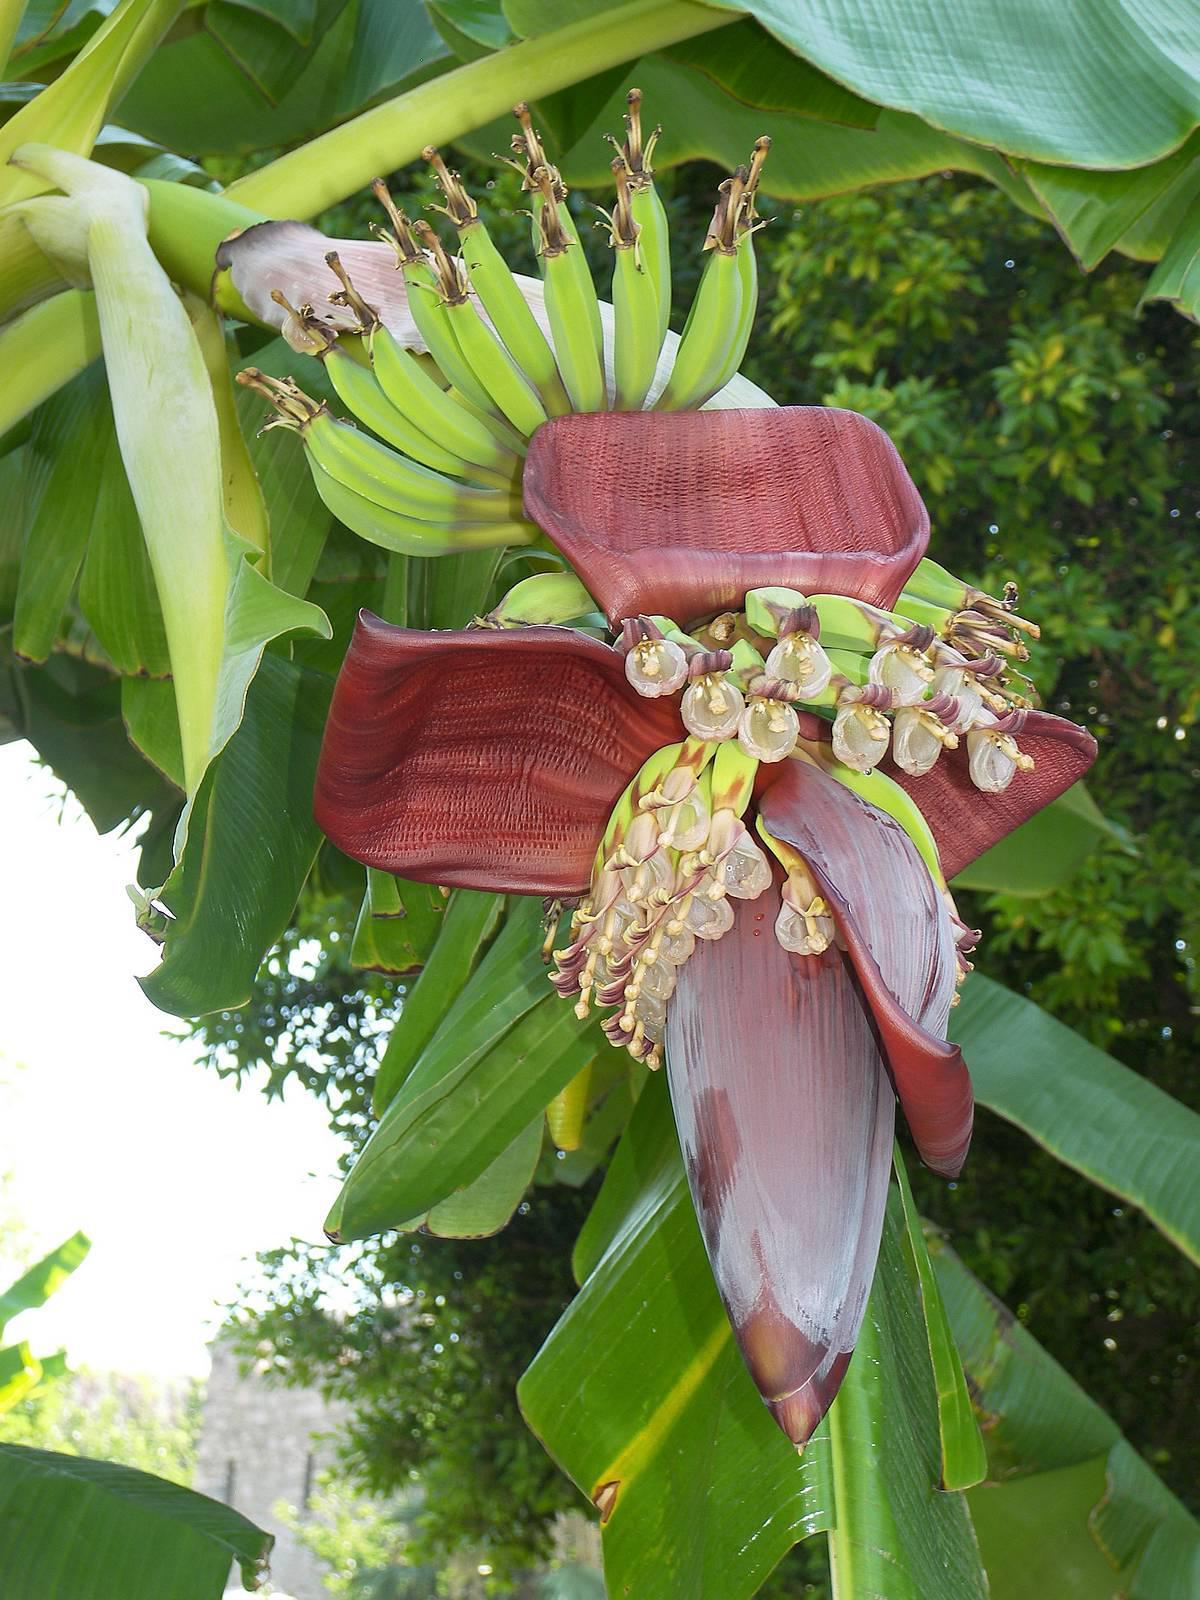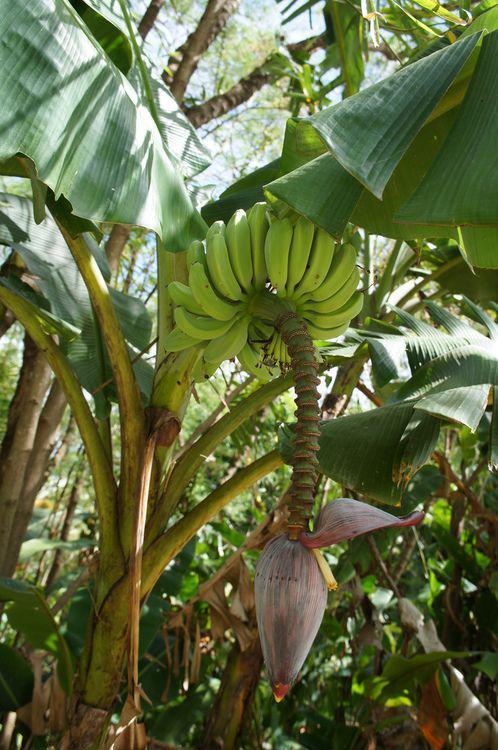The first image is the image on the left, the second image is the image on the right. Considering the images on both sides, is "The image on the left has at least one dark red petal" valid? Answer yes or no. Yes. 